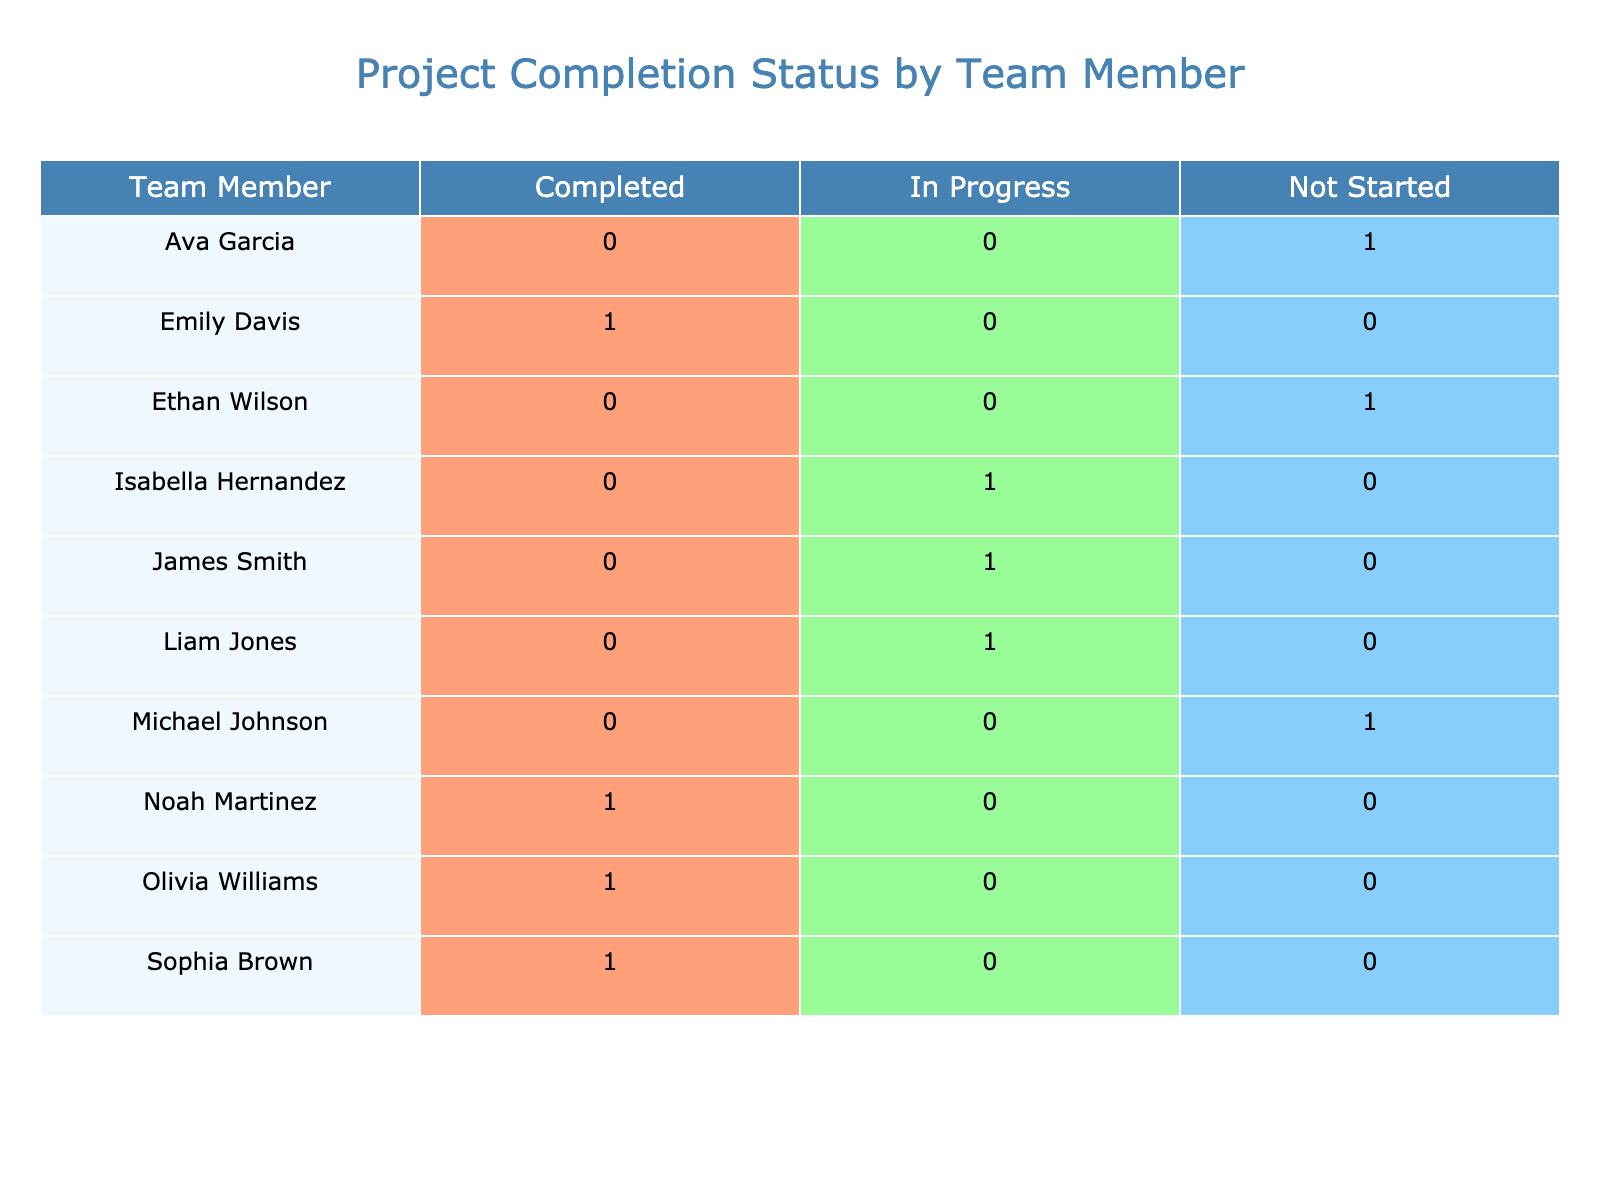What is the completion status of Noah Martinez's project? Noah Martinez is listed under the 'Team Member' column, and his 'Completion Status' is found in the corresponding column of the table. It shows that Noah Martinez's project status is 'Completed'.
Answer: Completed How many team members have their projects marked as 'In Progress'? To find the number of team members with the status 'In Progress', we count the occurrences of this status in the 'Completion Status' column. There are three team members with this status: James Smith, Liam Jones, and Isabella Hernandez.
Answer: 3 Which project has the nearest deadline that is 'Not Started'? We look for projects labeled as 'Not Started' and check their respective deadlines. Michael Johnson has a deadline of 2023-11-01 and Ava Garcia has a deadline of 2023-10-20. Since 2023-10-20 is the nearest, the project is 'Customer Feedback Analysis' by Ava Garcia.
Answer: Customer Feedback Analysis Is there any team member who has completed their project with a deadline after October 15? We need to check the projects that are marked 'Completed' and see if any of their deadlines are beyond October 15. The only project that fits is Michael Johnson’s project, 'Data Migration', which has a deadline of 2023-11-01. Therefore, the answer is yes.
Answer: Yes What is the total number of projects that have been completed by the team? We aggregate the counts of 'Completed' statuses in the 'Completion Status' column. The completed projects belong to Emily Davis, Sophia Brown, Olivia Williams, and Noah Martinez, resulting in a total of four completed projects.
Answer: 4 Identify the team member with the most projects in the 'Not Started' category. Looking at the 'Completion Status' column, we see that three projects are listed as 'Not Started': Michael Johnson, Ava Garcia, and Ethan Wilson. Therefore, none of the team members have more than one project in the 'Not Started' category, making them all equal.
Answer: No one has more What is the ratio of completed projects to in-progress projects? The completed projects count is four (Emily Davis, Sophia Brown, Olivia Williams, and Noah Martinez), and the in-progress projects count is three (James Smith, Liam Jones, and Isabella Hernandez). Understanding this gives us a ratio of completed to in-progress projects of 4:3.
Answer: 4:3 How many projects are scheduled to be completed before October? By inspecting the deadlines, we find that 4 projects (Olivia Williams, Noah Martinez, Emily Davis, and Sophia Brown) are completed before October.
Answer: 4 